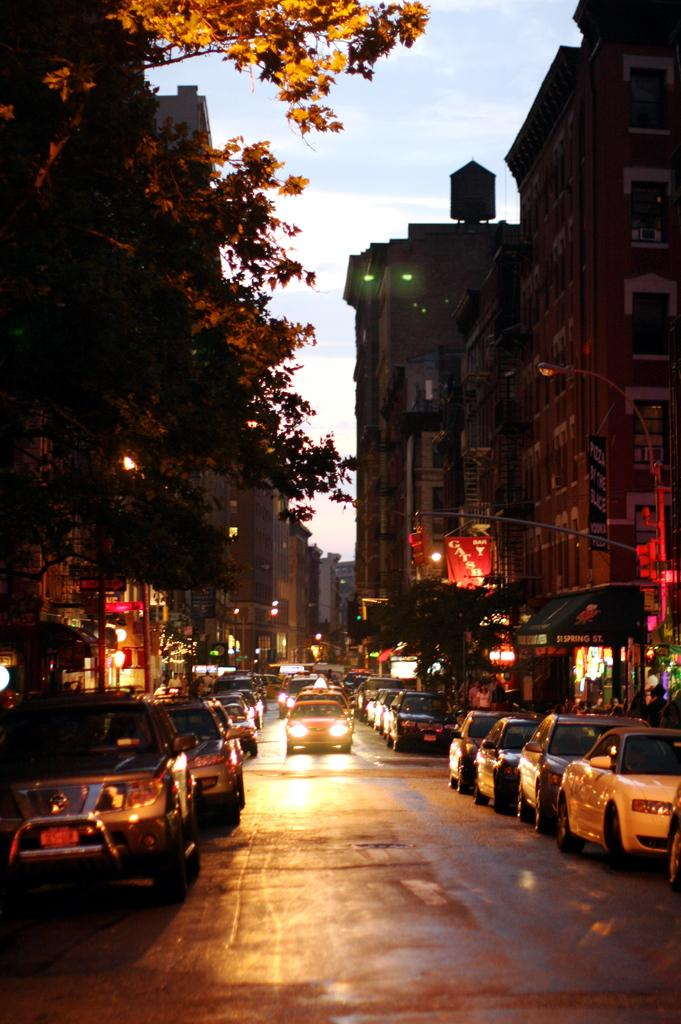What type of structures can be seen in the image? There are buildings in the image. What other natural elements are present in the image? There are trees in the image. What mode of transportation can be seen on the road in the image? There are cars on the road in the image. What can be seen in the background of the image? The sky is visible in the background of the image. Can you recall the memory of the horse that was present in the image? There is no horse present in the image, so there is no memory to recall. 